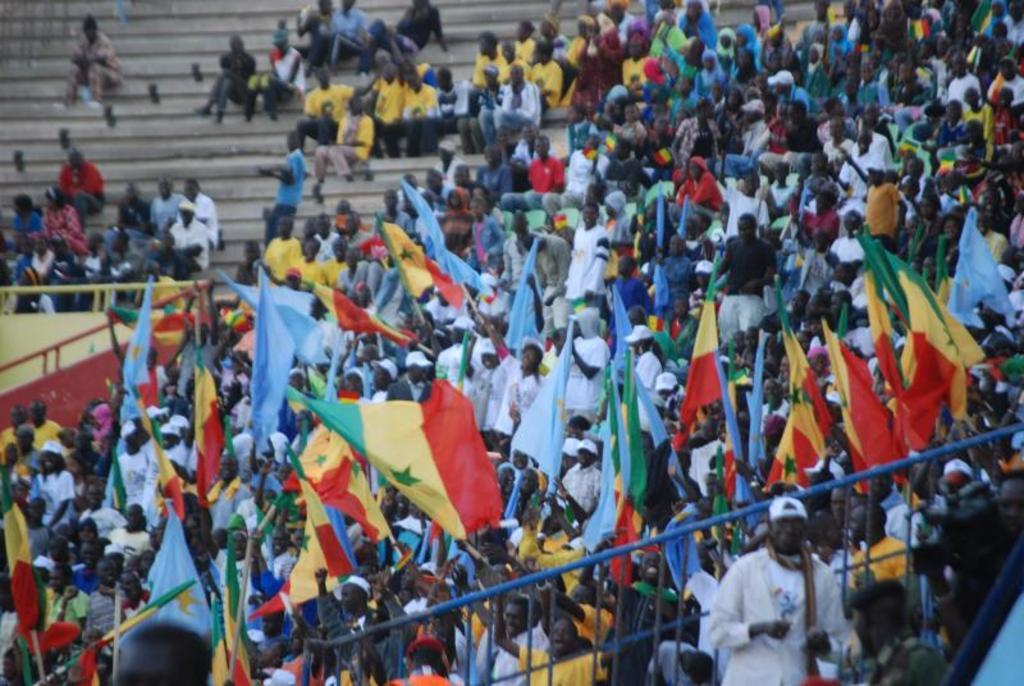What are the people in the image doing? The people in the image are standing and sitting on the stairs. What are the people holding in the image? The people are holding flags in the image. What can be seen in the background of the image? There is a fence in the image. What else is present in the image besides the people and the fence? There is an object in the image. What type of brass instrument is being played on the table in the image? There is no brass instrument or table present in the image. 